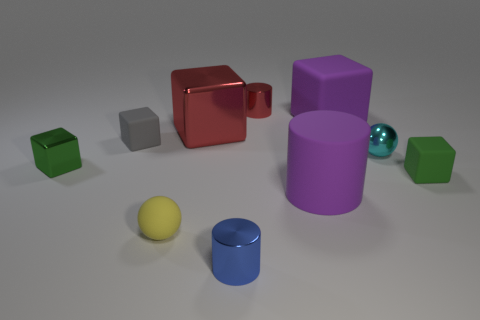Subtract all metallic cubes. How many cubes are left? 3 Subtract all brown balls. How many green cubes are left? 2 Subtract 1 balls. How many balls are left? 1 Subtract all yellow spheres. How many spheres are left? 1 Subtract all cylinders. How many objects are left? 7 Subtract all large blocks. Subtract all gray spheres. How many objects are left? 8 Add 8 blue cylinders. How many blue cylinders are left? 9 Add 9 green shiny cylinders. How many green shiny cylinders exist? 9 Subtract 0 brown cylinders. How many objects are left? 10 Subtract all blue cylinders. Subtract all blue balls. How many cylinders are left? 2 